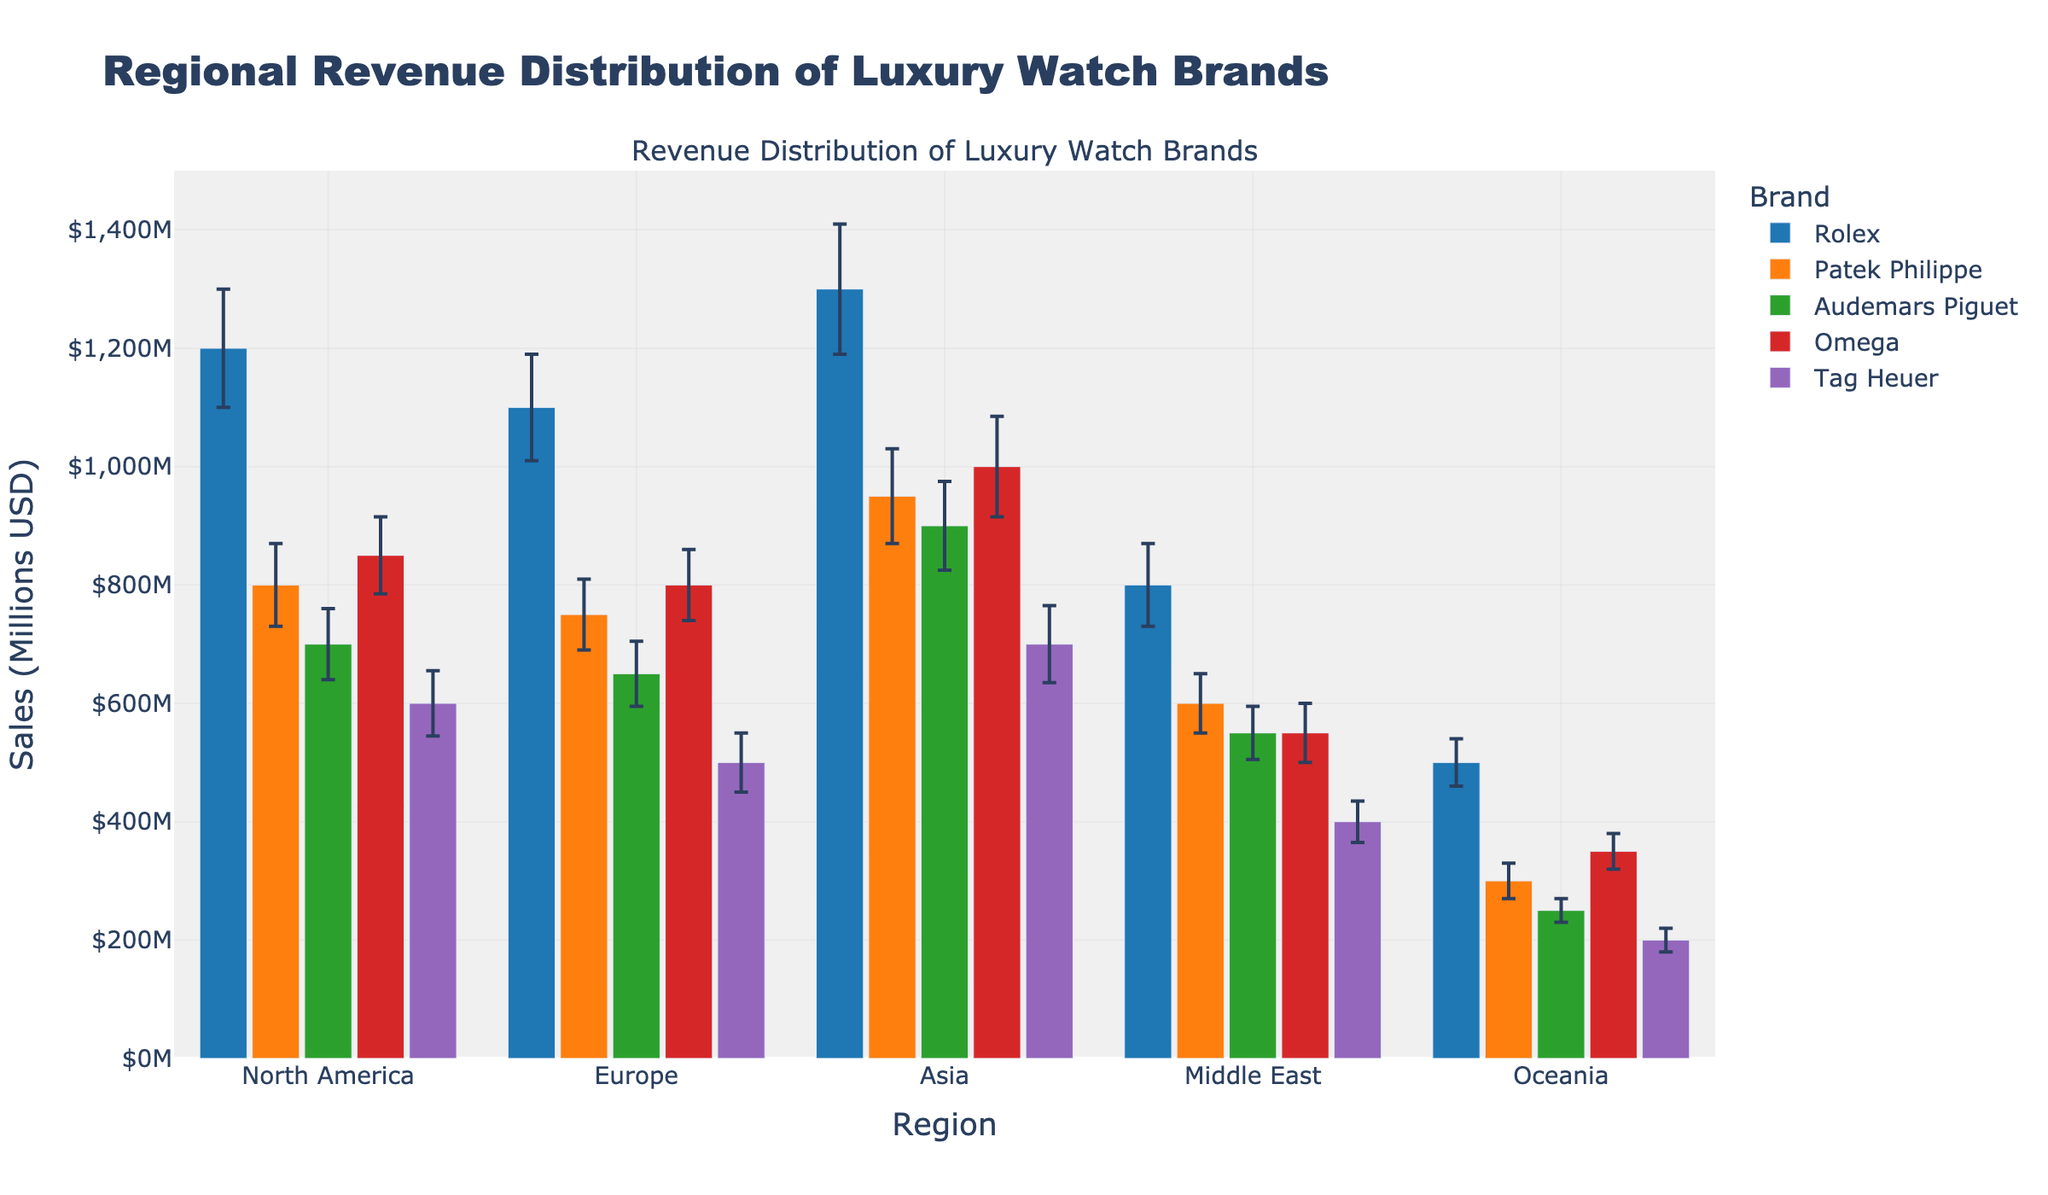What is the title of the chart? The title is located at the top of the chart and is usually in a larger, bold font. It summarizes what the chart is about. Here, it reads "Regional Revenue Distribution of Luxury Watch Brands."
Answer: Regional Revenue Distribution of Luxury Watch Brands What are the regions represented on the x-axis? The x-axis labels represent the different regions where the sales are measured. From the figure, the regions are "North America," "Europe," "Asia," "Middle East," and "Oceania."
Answer: North America, Europe, Asia, Middle East, Oceania Which luxury watch brand has the highest sales in Asia? Observing the bar heights for the "Asia" region across all the brands, the tallest bar indicates the highest sales. Rolex has the highest bar in Asia.
Answer: Rolex What is the sales figure and error for Patek Philippe in Europe? Look at the bar for Patek Philippe in the Europe region. The hover information or the bar label would indicate the sales value as $750M and the error as ±$60M.
Answer: $750M, ±$60M Compare the total sales of Audemars Piguet in North America and Europe. Which is higher and by how much? Find the bar heights for Audemars Piguet in both regions. North America has sales of $700M, and Europe has $650M. Subtracting the two gives the difference. $700M - $650M = $50M.
Answer: North America by $50M Which brand has the smallest error in sales within Oceania? Comparing the error bars for all brands in the Oceania region, the smallest one belongs to Audemars Piguet, which has an error of ±$20M.
Answer: Audemars Piguet What is the combined sales figure of Tag Heuer across all regions? Add the sales figures of Tag Heuer from each region: $600M (North America) + $500M (Europe) + $700M (Asia) + $400M (Middle East) + $200M (Oceania) = $2400M.
Answer: $2400M Between Omega and Rolex, which brand has higher sales in Europe, and by how much? Compare the bar heights for Omega and Rolex in Europe. Rolex has $1100M and Omega has $800M. The difference is $1100M - $800M = $300M.
Answer: Rolex by $300M What’s the average sales error for Omega across all regions? Calculate the average by adding all the errors for Omega and dividing by the number of regions. (65 + 60 + 85 + 50 + 30) / 5 = 58.
Answer: 58 How do the sales of Patek Philippe in Asia compare to those in the Middle East? Compare the sales figures for Patek Philippe in Asia and the Middle East. Asia has $950M and the Middle East has $600M, so Asia has higher sales.
Answer: Asia has higher sales 